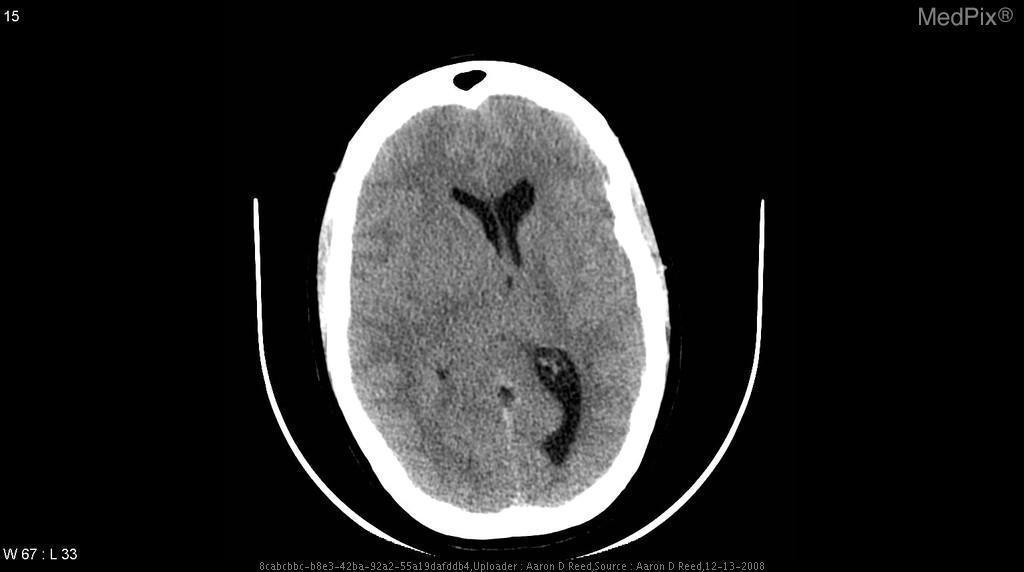Is the corpus callosum involved?
Write a very short answer. Yes. Do you see a subdural hematoma?
Write a very short answer. No. Is there a subdural hematoma?
Concise answer only. No. Which ventricles are visible?
Be succinct. Lateral ventricles. How long does this imaging modality take to complete? (hours?	minutes?)
Give a very brief answer. ~15 minutes	potentially faster with newer imaging systems. Can you appreciate a shift of the midline?
Write a very short answer. Yes. Is there a midline shift?
Write a very short answer. Yes. Can a diagnosis or impression be made in this plane?
Quick response, please. Yes. Does the skull appear fractured?
Give a very brief answer. No. Is there a skull fracture?
Answer briefly. No. 